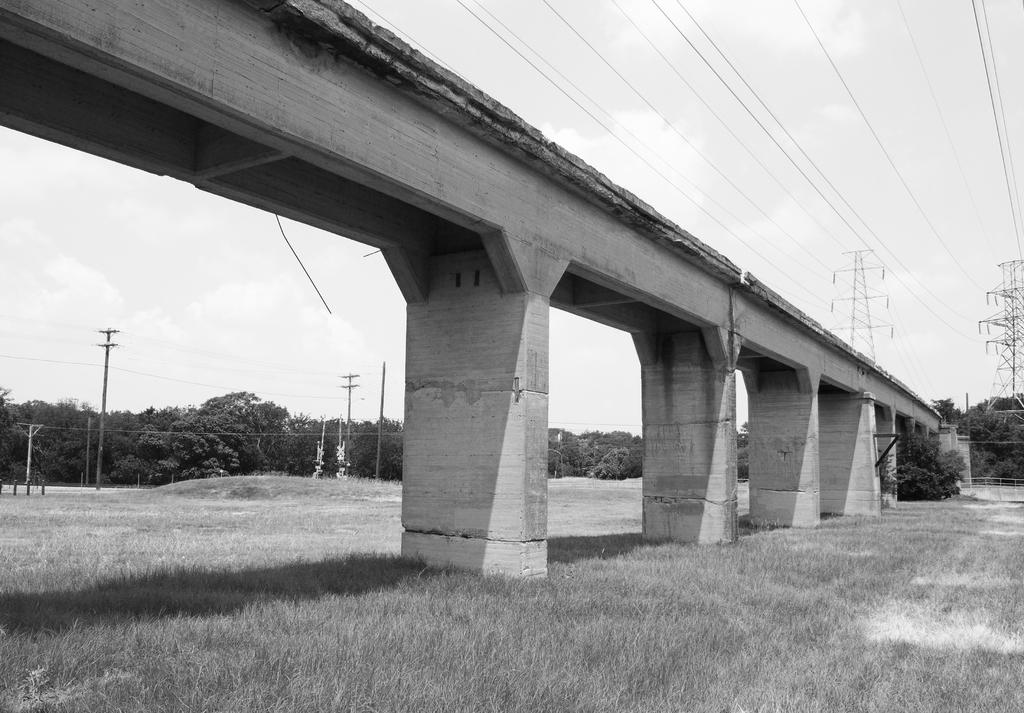What type of structure is present in the image? There is a concrete bridge in the image. Where is the bridge located? The bridge is on a green lawn. What can be seen above the bridge? There is a huge electric pole and cables above the bridge. What is visible in the background of the image? There are trees and electric poles in the background of the image. Can you see the sun playing hide-and-seek with the trees in the image? The sun is not visible in the image, and there is no mention of it playing hide-and-seek with the trees. 